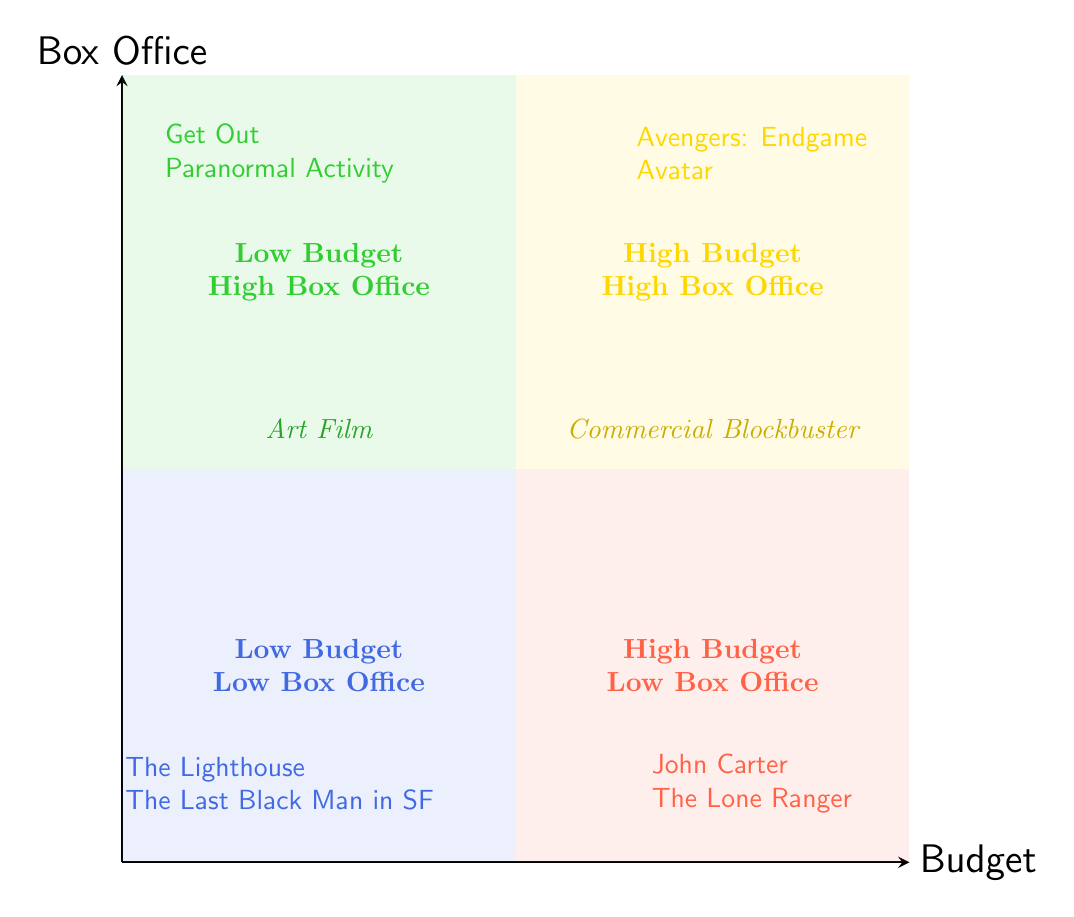What are the examples of films in the High Budget, High Box Office quadrant? The High Budget, High Box Office quadrant includes films "Avengers: Endgame" and "Avatar." This can be found by identifying the titles listed in that quadrant.
Answer: Avengers: Endgame, Avatar How much was the budget for "Get Out"? The budget for "Get Out" is listed in the Low Budget, High Box Office quadrant, where it states "$4.5 million" as the budget.
Answer: $4.5 million Which quadrant contains the most successful film in terms of box office revenue? The most successful film in terms of box office revenue is "Avatar," which is found in the High Budget, High Box Office quadrant. The diagram shows this by positioning the highest box office amounts in that section.
Answer: High Budget, High Box Office How many films are categorized as Low Budget, Low Box Office? There are two films listed in the Low Budget, Low Box Office quadrant: "The Lighthouse" and "The Last Black Man in San Francisco." Counting the listed examples in that quadrant gives the total.
Answer: 2 What type of film has a budget of "$15,000"? The film with a budget of "$15,000" is "Paranormal Activity," located in the Low Budget, High Box Office quadrant, indicating it's an Art Film.
Answer: Art Film Which quadrant holds films that failed to recoup their budgets significantly? The High Budget, Low Box Office quadrant is where films that failed to recoup their budgets, like "John Carter" and "The Lone Ranger," are located. The budgeting vs. box office performance indicates their lackluster financial returns.
Answer: High Budget, Low Box Office What is the relationship between budget size and box office performance for Art Films? For Art Films, the relationship is that films like "Get Out" and "Paranormal Activity" show low budgets yet high box office earnings, which signifies a successful financial performance relative to their costs.
Answer: Low budget, High box office Name a commercial blockbuster with a high budget but low box office returns. "John Carter" is an example of a commercial blockbuster with a high budget of "$263 million" but low box office returns of "$284 million," found in the High Budget, Low Box Office quadrant.
Answer: John Carter 